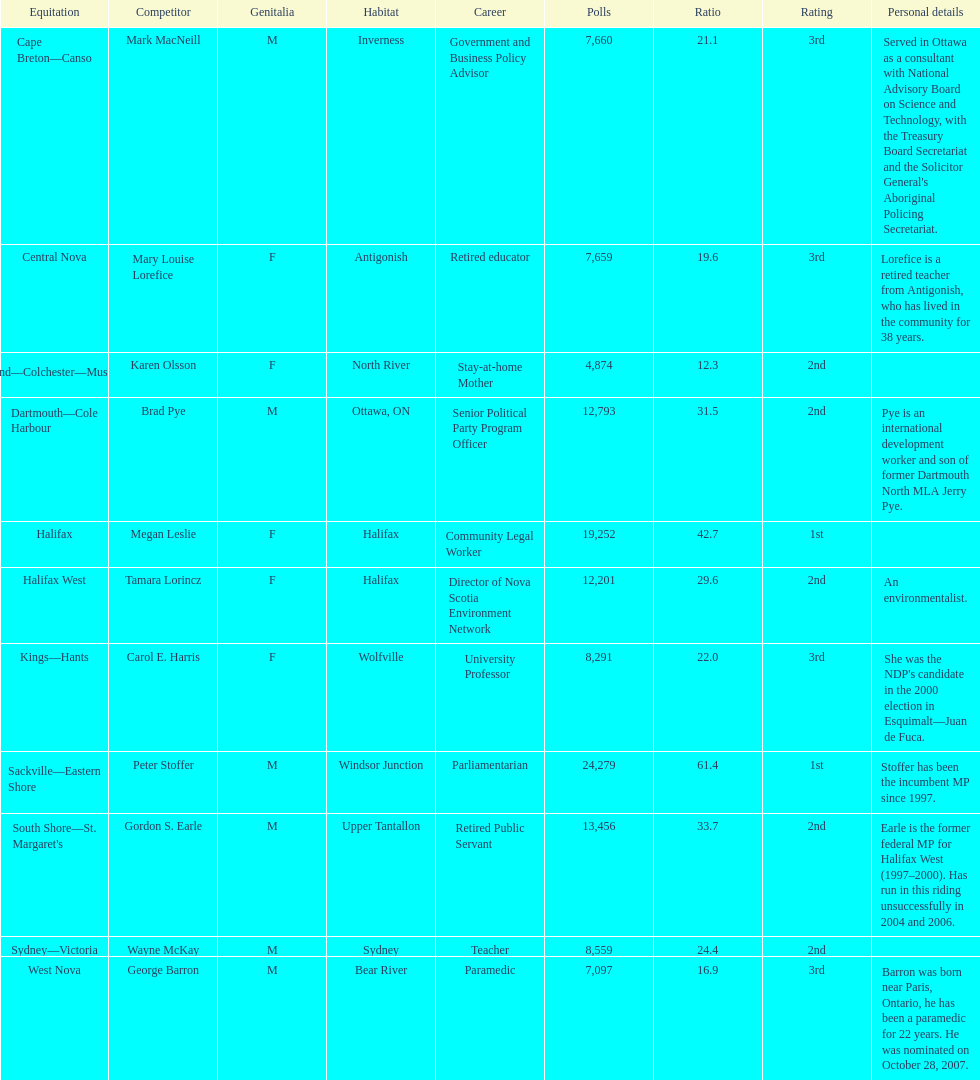How many of the candidates were females? 5. 